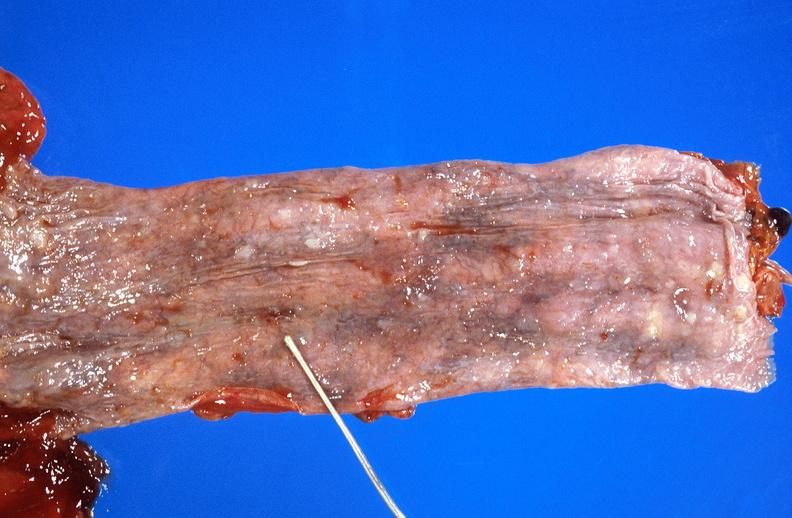does this image show esophageal varices due to alcoholic cirrhosis?
Answer the question using a single word or phrase. Yes 